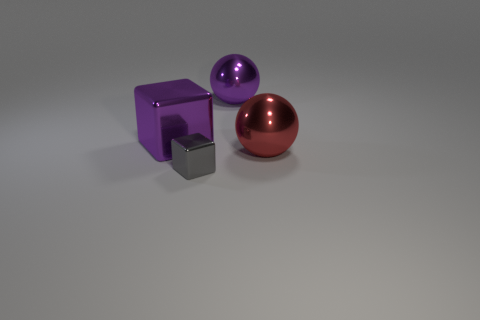How many big green shiny things are the same shape as the big red shiny object?
Make the answer very short. 0. There is a ball in front of the big purple metal object that is on the right side of the tiny gray shiny object; what is its material?
Make the answer very short. Metal. What is the size of the purple thing on the right side of the tiny cube?
Ensure brevity in your answer.  Large. What number of blue things are either balls or large blocks?
Provide a short and direct response. 0. Is there anything else that has the same material as the gray cube?
Your response must be concise. Yes. What material is the other object that is the same shape as the tiny gray object?
Give a very brief answer. Metal. Are there the same number of large metal balls that are in front of the red metallic ball and large gray rubber blocks?
Keep it short and to the point. Yes. There is a shiny thing that is both right of the purple shiny cube and behind the big red sphere; what is its size?
Provide a succinct answer. Large. Are there any other things that have the same color as the big cube?
Keep it short and to the point. Yes. There is a metal block that is on the right side of the metal block that is behind the large red ball; what is its size?
Your answer should be compact. Small. 